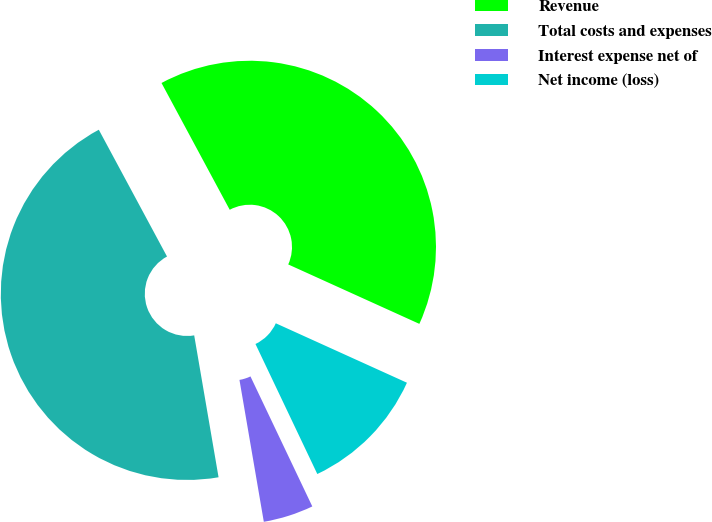Convert chart to OTSL. <chart><loc_0><loc_0><loc_500><loc_500><pie_chart><fcel>Revenue<fcel>Total costs and expenses<fcel>Interest expense net of<fcel>Net income (loss)<nl><fcel>39.63%<fcel>44.85%<fcel>4.36%<fcel>11.16%<nl></chart> 